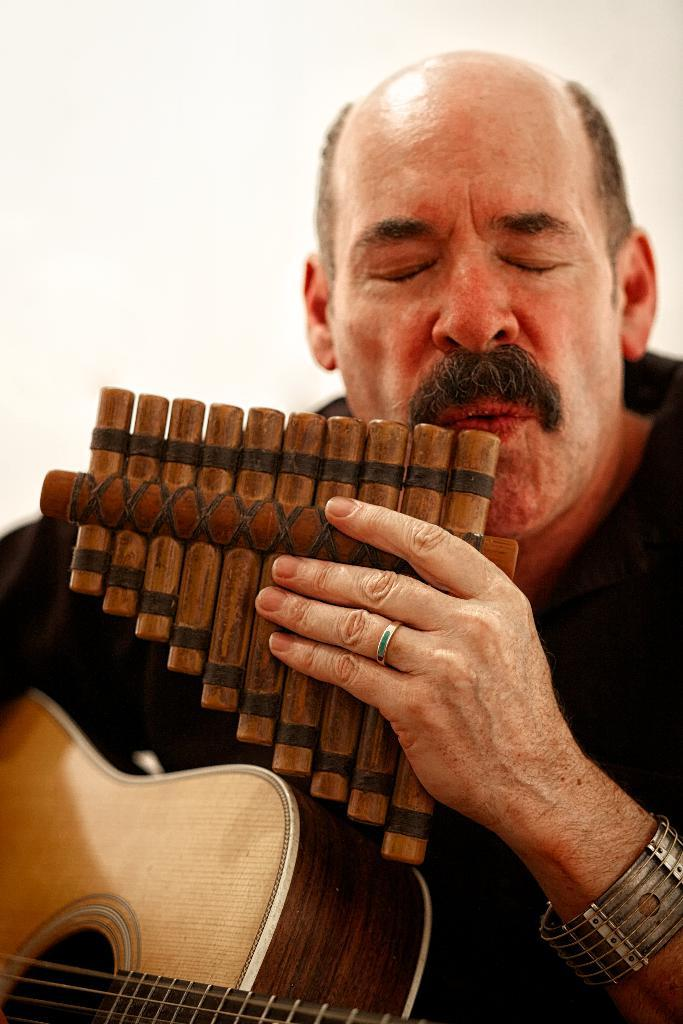What is the main subject of the image? The main subject of the image is a man. What is the man holding in the image? The man is holding a guitar. How many arches can be seen in the image? There are no arches present in the image; it features a man holding a guitar. What type of snakes are slithering around the man's feet in the image? There are no snakes present in the image; it features a man holding a guitar. 